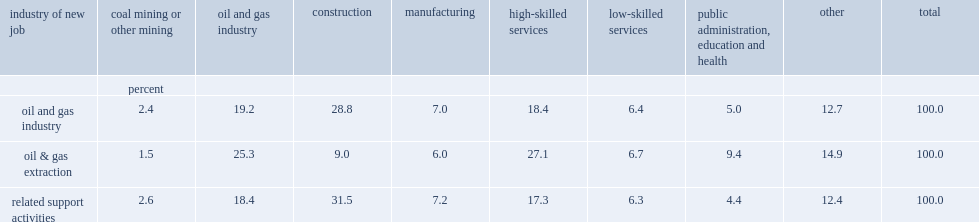What was the percent of people found a new job in construction? 28.8. What was the percent of people found a new position in highly skilled services? 18.4. What was the percent of people found a new position in highly skilled services? 7.0. 